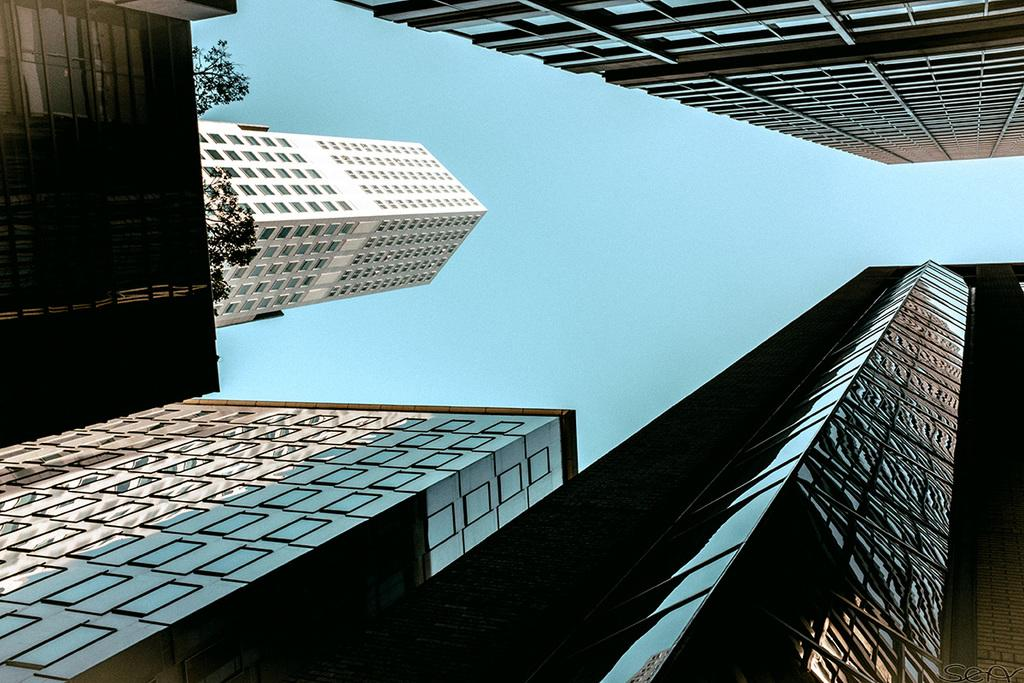What type of structures can be seen at the top of the image? There are buildings at the top of the image. What type of structures can be seen at the bottom of the image? There are buildings at the bottom of the image. What type of vegetation is on the left side of the image? There are trees on the left side of the image. What is visible in the middle of the image? The sky is visible in the middle of the image. Can you tell me how many birds are sleeping on the buildings in the image? There are no birds present in the image, so it is not possible to determine how many might be sleeping on the buildings. 